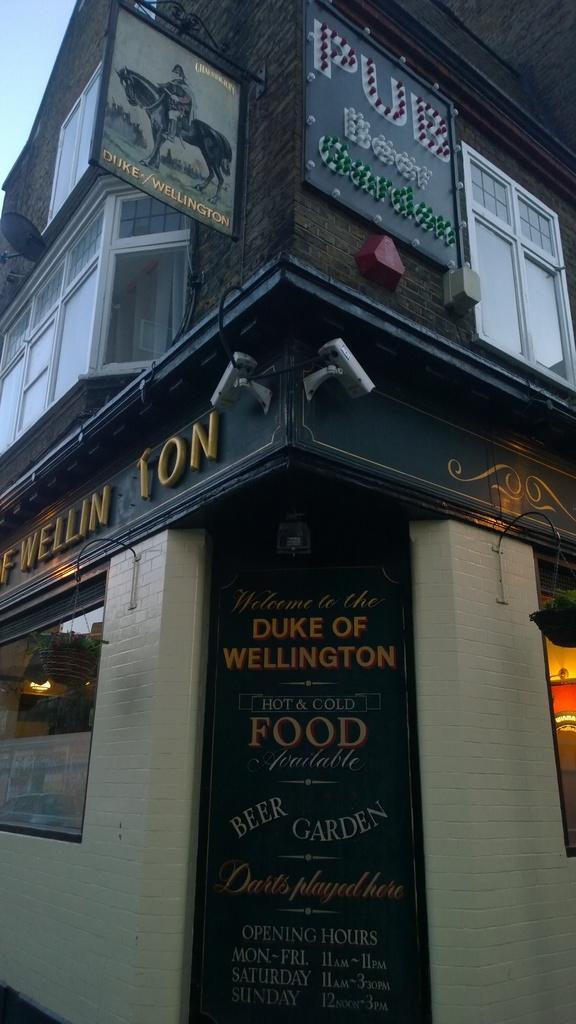Please provide a concise description of this image. In this picture I can see a building on which there are boards on which there is something written and I see the lights and I see the windows on the top of the building. 